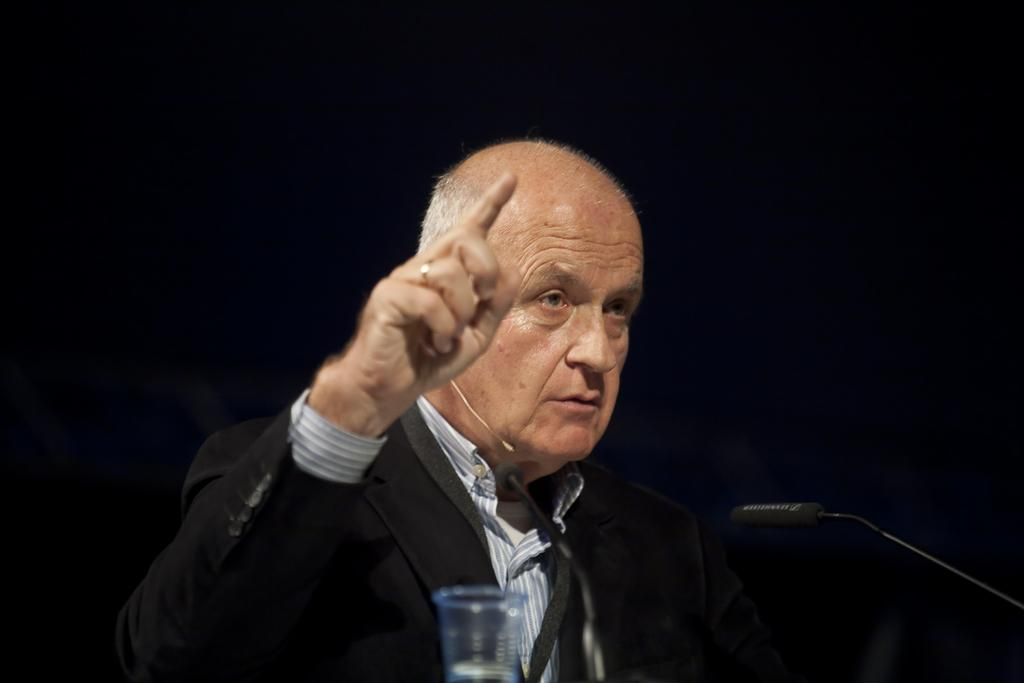What is the main subject of the image? There is a person in the image. What is the person doing in the image? The person is speaking into a microphone. Can you describe the background of the image? The background of the image is dark. What object is located at the bottom of the image? There is a glass at the bottom of the image. Can you tell me how many tigers are swinging their attention towards the person in the image? There are no tigers or swings present in the image, and therefore no such activity can be observed. 